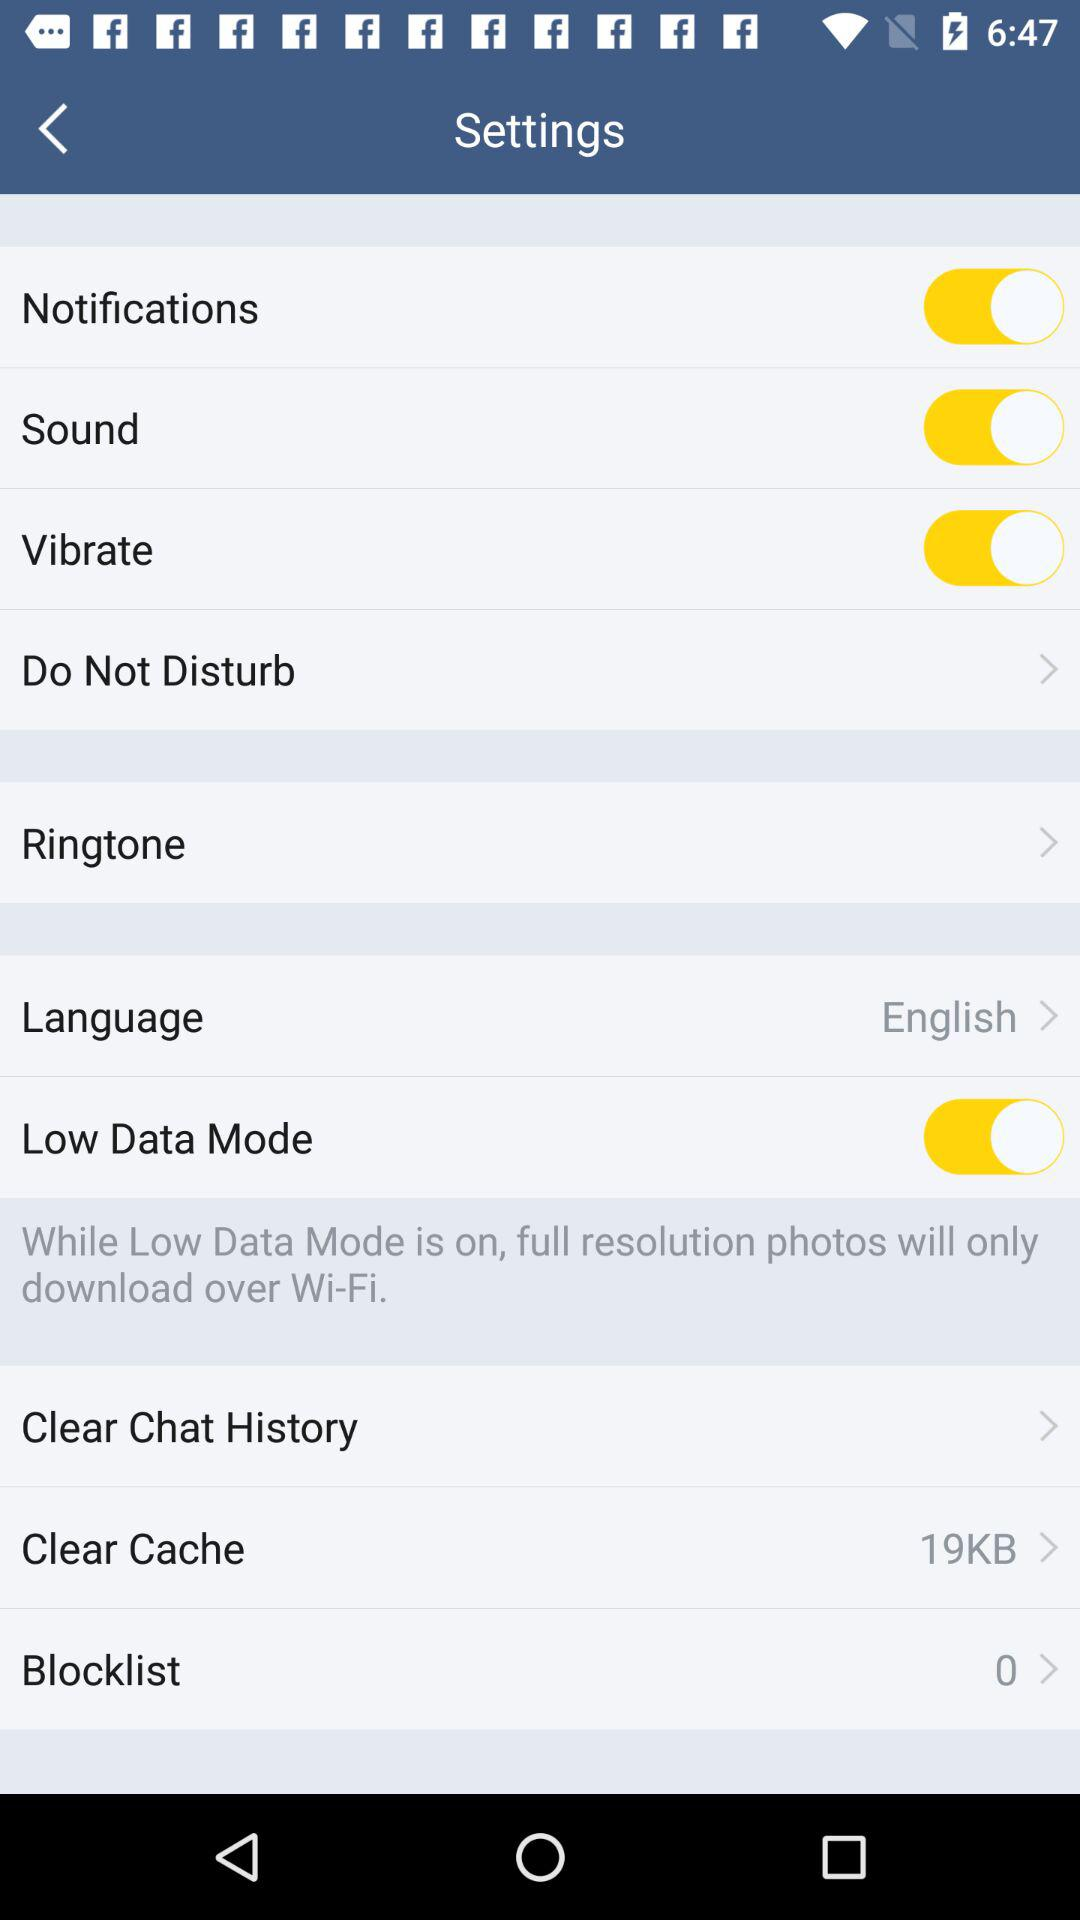What is the status of the "Notifications"? The status is "on". 